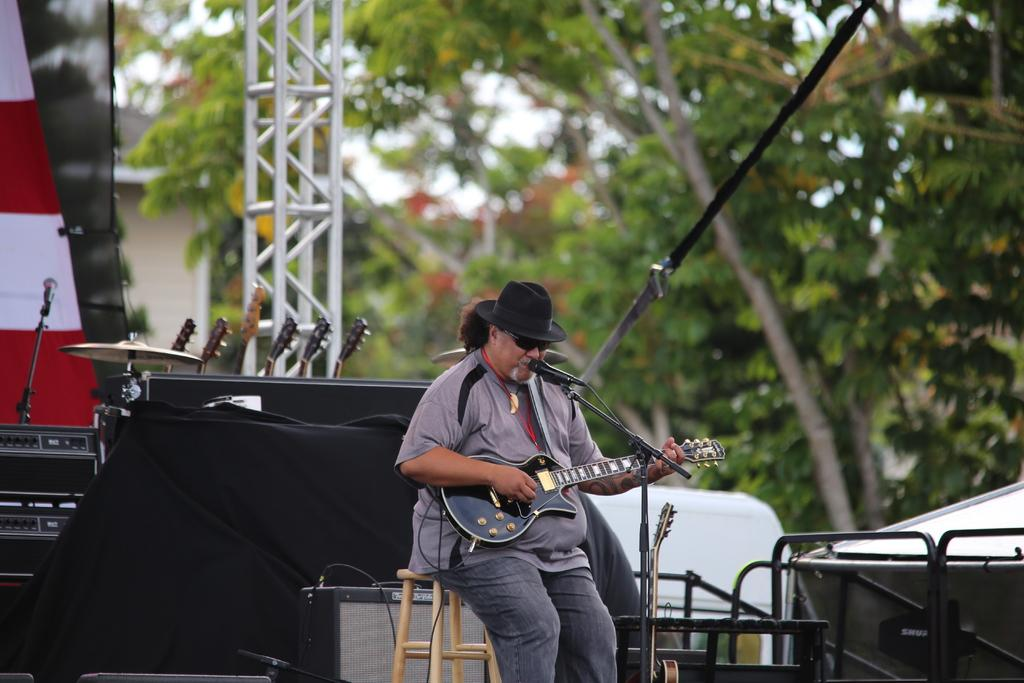Who is the main subject in the image? There is a man in the image. What is the man doing in the image? The man is sitting on a stool, playing the guitar, and singing into a microphone. What can be seen in the background of the image? There are musical instruments, a pillar, a tree, and a microphone in the background. What type of noise can be heard coming from the mountain in the image? There is no mountain present in the image, so it is not possible to determine what, if any, noise might be heard. 